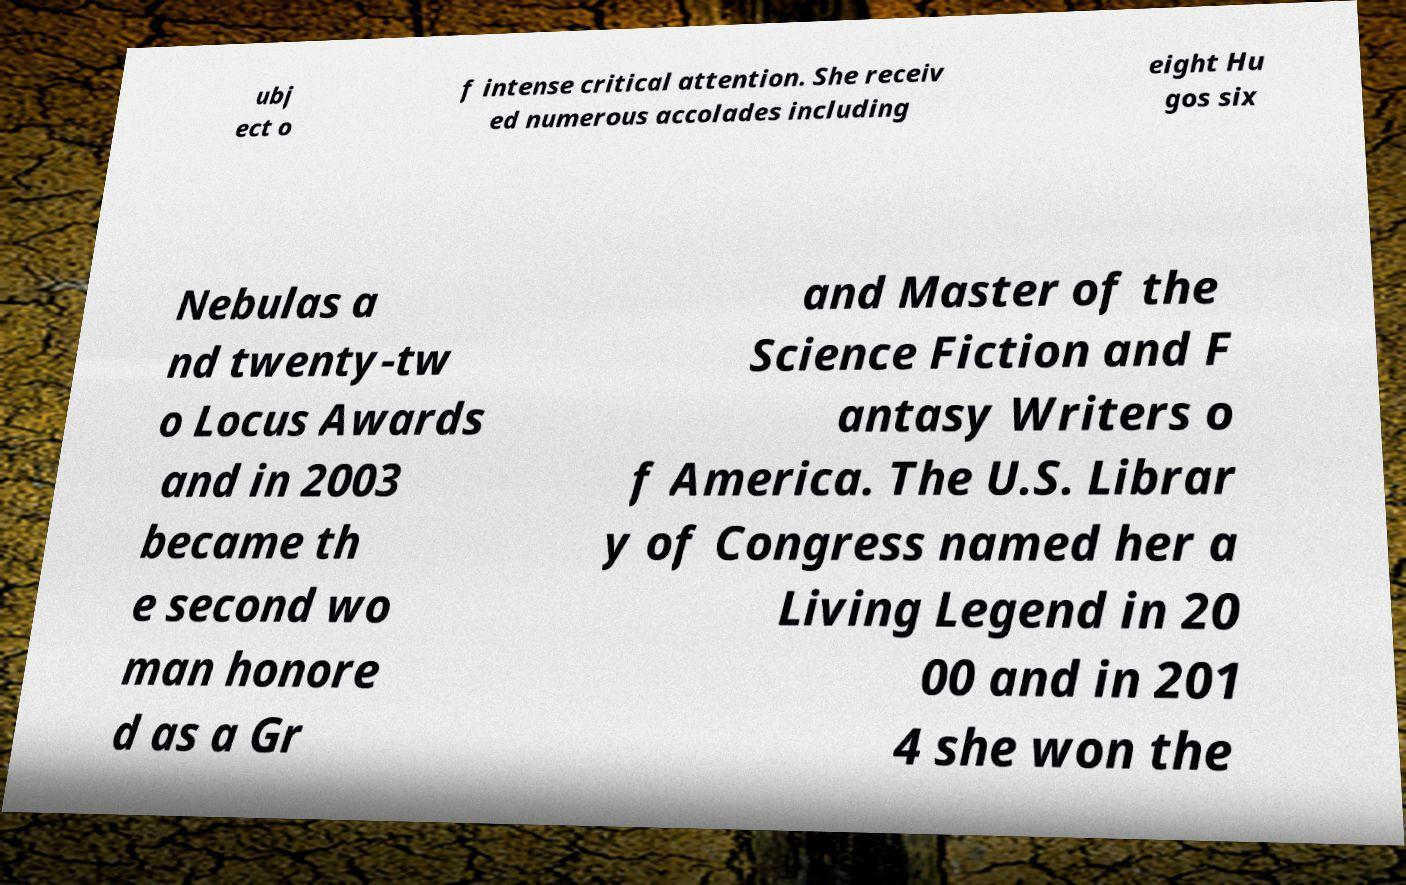Can you accurately transcribe the text from the provided image for me? ubj ect o f intense critical attention. She receiv ed numerous accolades including eight Hu gos six Nebulas a nd twenty-tw o Locus Awards and in 2003 became th e second wo man honore d as a Gr and Master of the Science Fiction and F antasy Writers o f America. The U.S. Librar y of Congress named her a Living Legend in 20 00 and in 201 4 she won the 